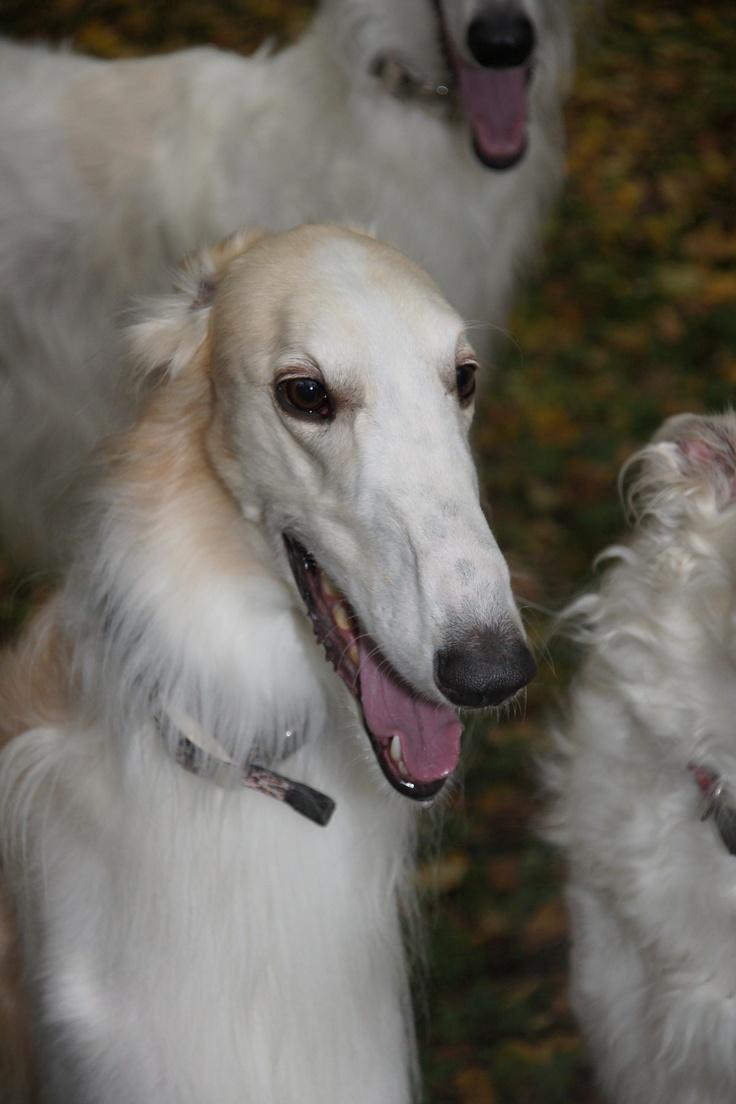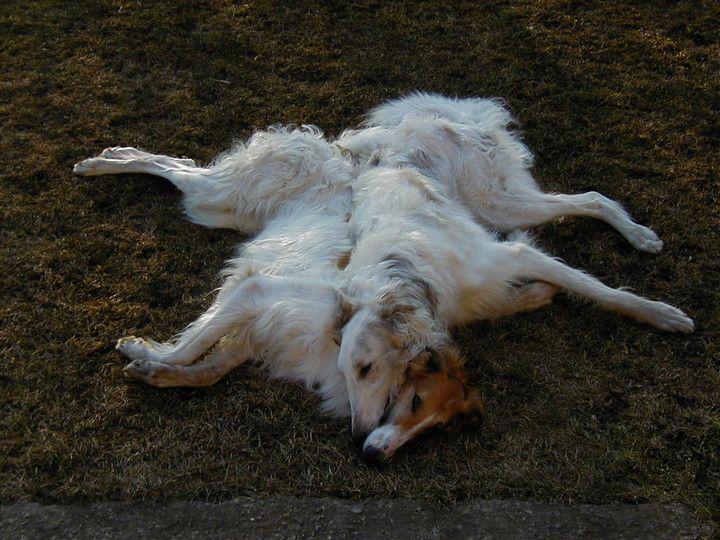The first image is the image on the left, the second image is the image on the right. For the images shown, is this caption "In one image there are two white dogs and in the other image there are three dogs." true? Answer yes or no. Yes. The first image is the image on the left, the second image is the image on the right. Given the left and right images, does the statement "Two hounds with left-turned faces are in the foreground of the left image, and the right image includes at least three hounds." hold true? Answer yes or no. No. 